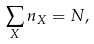<formula> <loc_0><loc_0><loc_500><loc_500>\sum _ { X } n _ { X } = N ,</formula> 